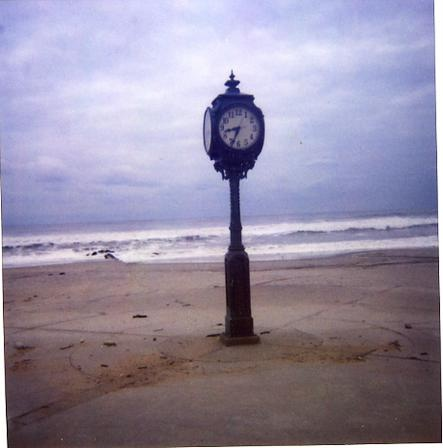Describe the objects in this image and their specific colors. I can see clock in darkgray, gray, purple, and navy tones and clock in darkgray, gray, navy, and purple tones in this image. 